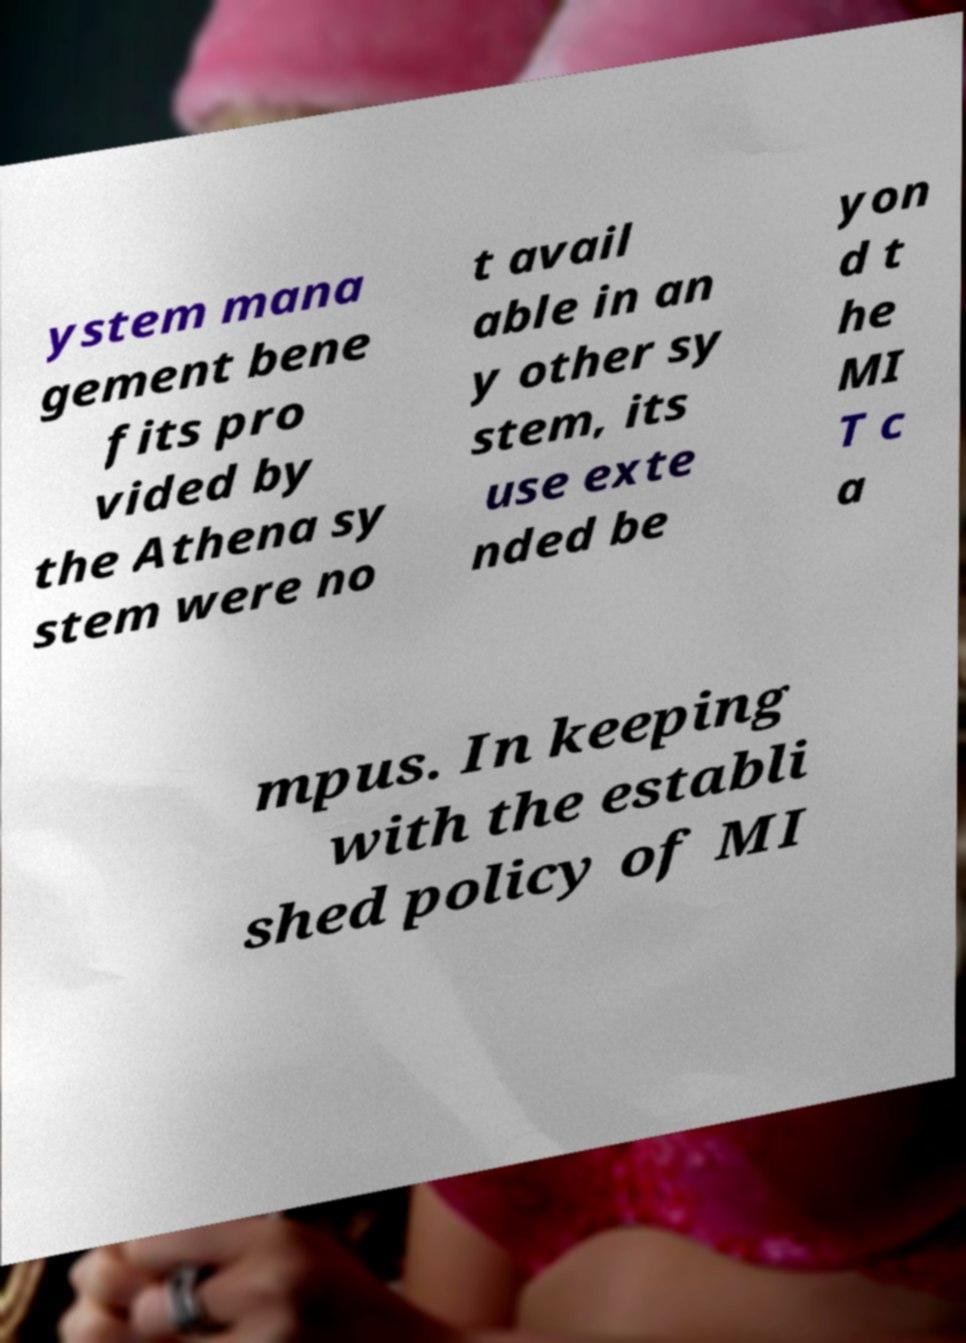Please read and relay the text visible in this image. What does it say? ystem mana gement bene fits pro vided by the Athena sy stem were no t avail able in an y other sy stem, its use exte nded be yon d t he MI T c a mpus. In keeping with the establi shed policy of MI 